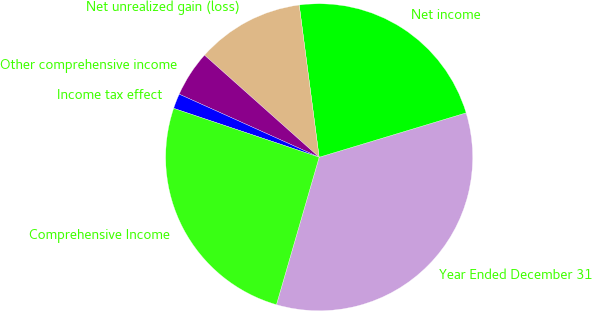<chart> <loc_0><loc_0><loc_500><loc_500><pie_chart><fcel>Year Ended December 31<fcel>Net income<fcel>Net unrealized gain (loss)<fcel>Other comprehensive income<fcel>Income tax effect<fcel>Comprehensive Income<nl><fcel>34.16%<fcel>22.41%<fcel>11.35%<fcel>4.84%<fcel>1.58%<fcel>25.67%<nl></chart> 